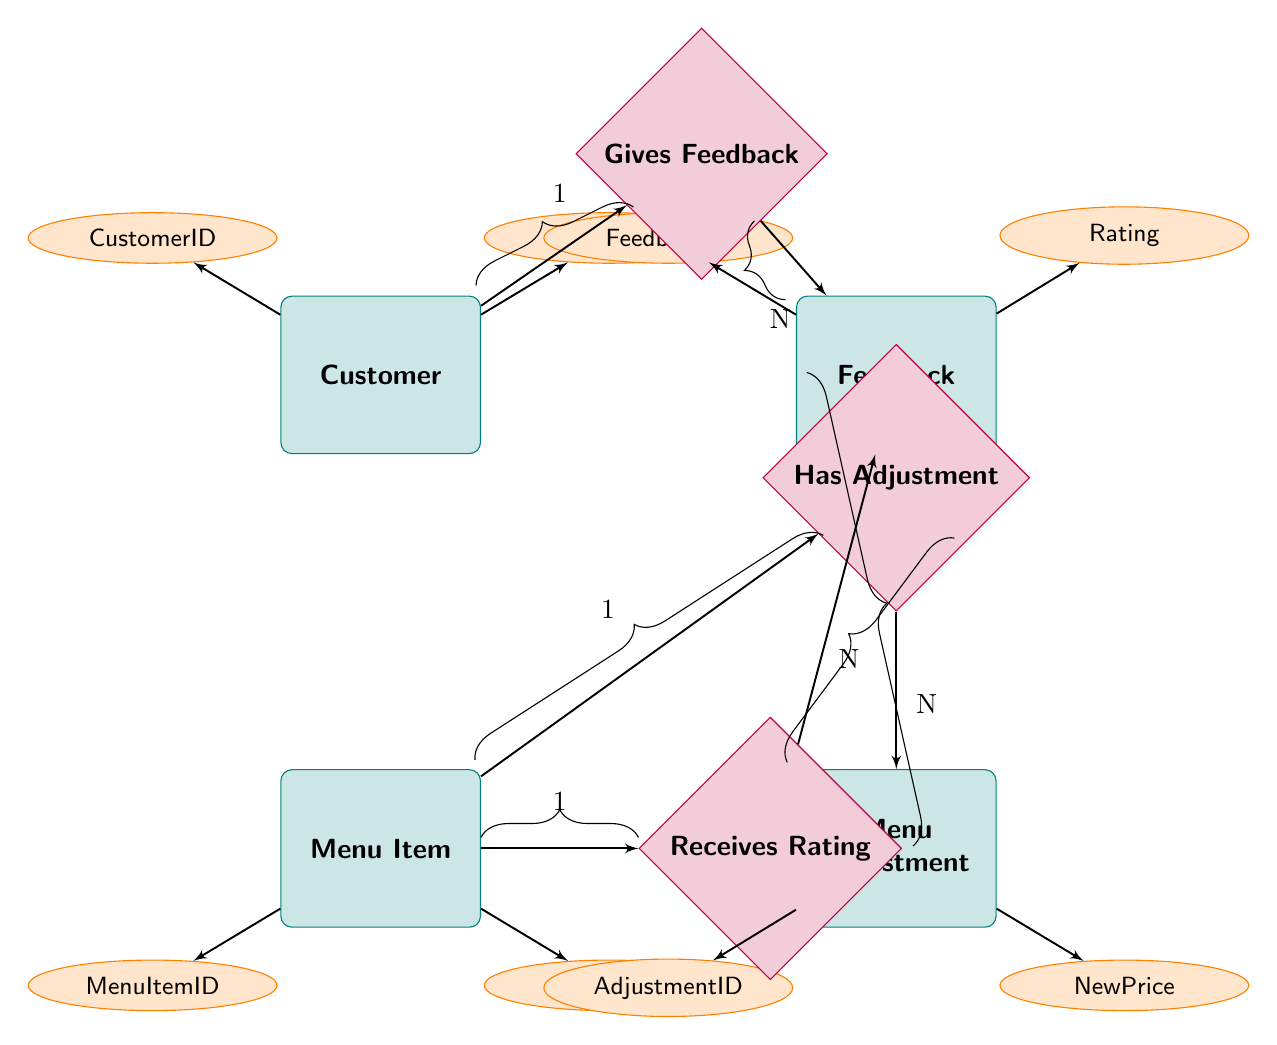What entity represents customer details? In the diagram, the entity that holds information about customers is labeled as "Customer." This entity includes attributes such as CustomerID, Name, Email, and Phone.
Answer: Customer How many main entities are in the diagram? The diagram features four main entities: Customer, Feedback, Menu Item, and Menu Adjustment. By counting them, the total is four entities.
Answer: 4 What relationship connects Customer and Feedback entities? The relationship that connects the Customer entity to the Feedback entity is labeled as "Gives Feedback." This indicates that customers provide feedback.
Answer: Gives Feedback Which entity is associated with Menu Adjustments? The entity linked to Menu Adjustments is labeled as "Menu Item." Each menu item can undergo one or more adjustments, as represented in the diagram.
Answer: Menu Item How many attributes does the Feedback entity have? The Feedback entity contains five attributes: FeedbackID, CustomerID, MenuItemID, Rating, Comments, and Date. Counting these attributes gives a total of five.
Answer: 5 What is the relationship type between Menu Item and Feedback? The relationship between Menu Item and Feedback is defined as "1:N," meaning each menu item may receive feedback from multiple sources, while each feedback corresponds to one menu item.
Answer: 1:N What is the purpose of the Menu Adjustment entity? The Menu Adjustment entity serves to record changes made to menu items, including attributes such as OldPrice, NewPrice, Reason, and Date of adjustment.
Answer: To record changes to menu items Can a Customer give multiple pieces of feedback? Yes, each customer can provide multiple feedback entries, as indicated by the "1:N" relationship from Customer to Feedback. This reflects that one customer may issue many feedback reports.
Answer: Yes What is the key identifier for the MenuItem entity? The key identifier for the MenuItem entity is MenuItemID, which uniquely identifies each menu item listed in the entity.
Answer: MenuItemID 